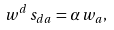<formula> <loc_0><loc_0><loc_500><loc_500>w ^ { d } \, s _ { d a } = \alpha \, w _ { a } ,</formula> 